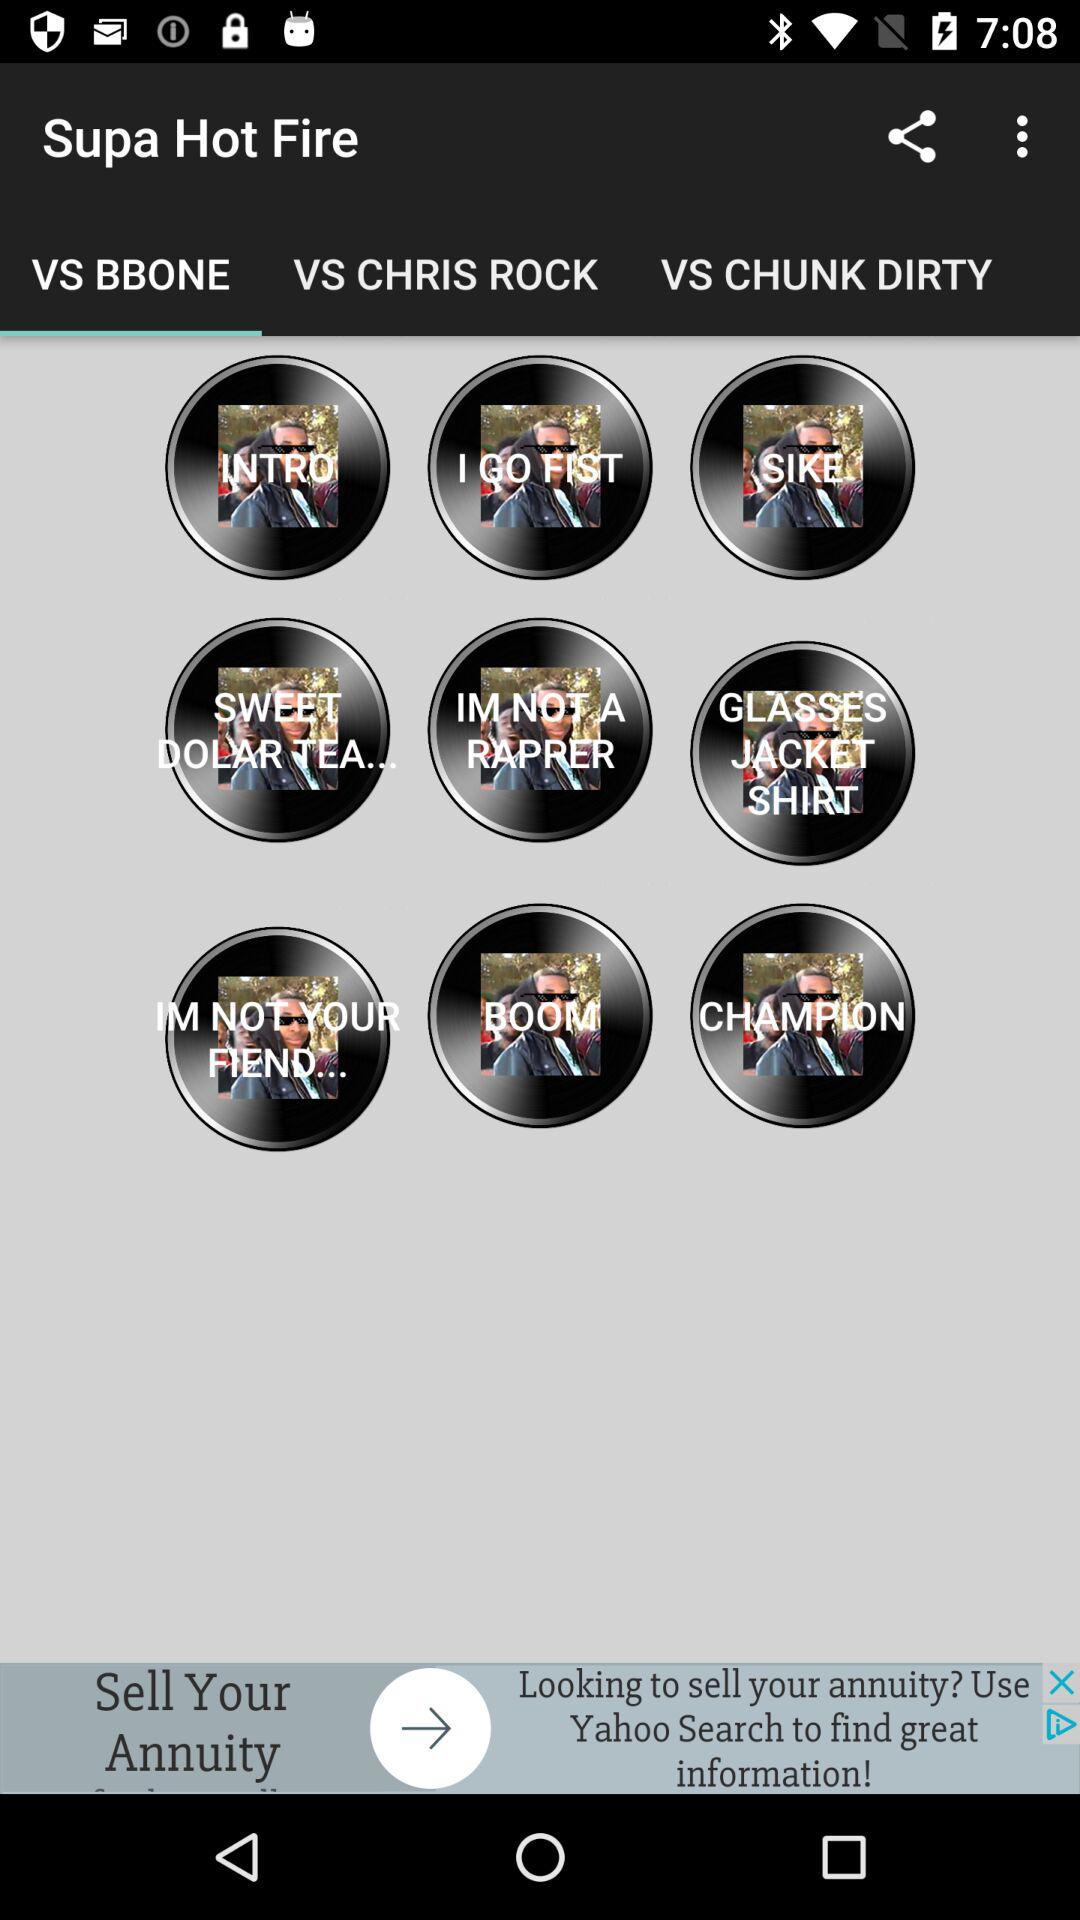Which tab is selected? The selected tab is "VS BBONE". 